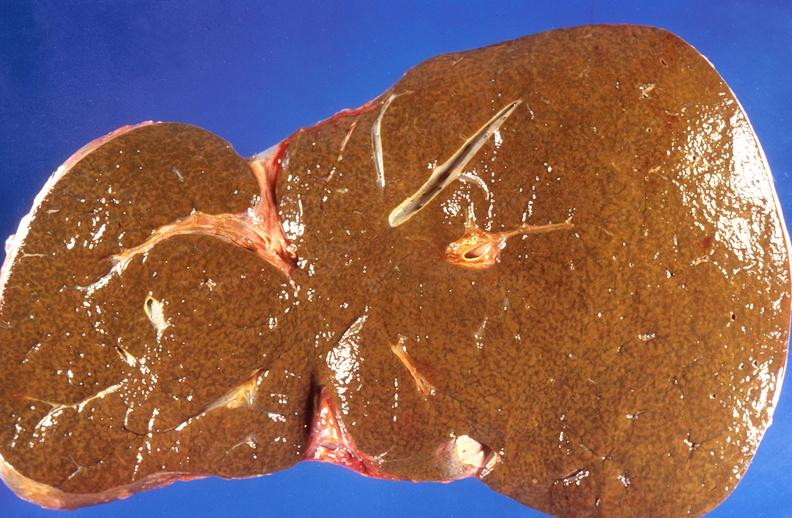s there present?
Answer the question using a single word or phrase. No 